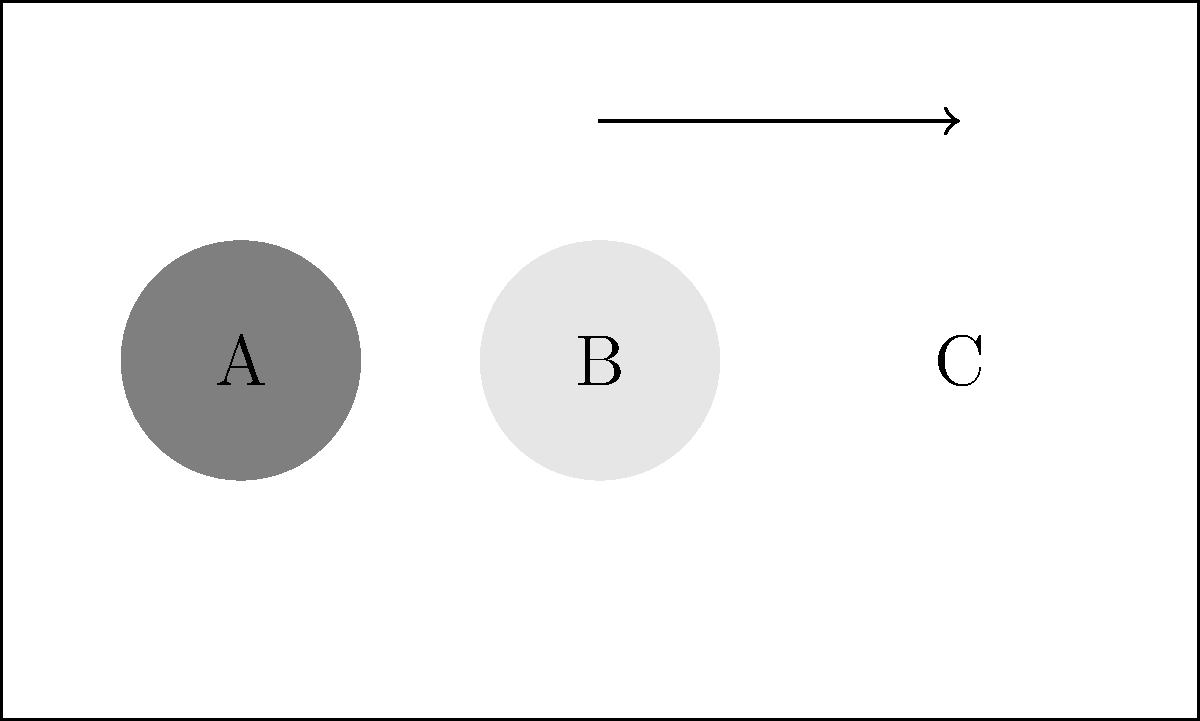You're arranging a display shelf for a new collection of designer accessories. The shelf currently has three circular items placed as shown: a dark gray clutch (A), a light gray wallet (B), and a white handbag (C). To create a more visually appealing display, you decide to rotate the arrangement 90 degrees clockwise. What will be the new order of the accessories from left to right? To solve this spatial rotation problem, let's follow these steps:

1. Identify the current order: The current order from left to right is A (dark gray), B (light gray), C (white).

2. Visualize the rotation: A 90-degree clockwise rotation means the rightmost item will become the leftmost item.

3. Apply the rotation:
   - C (white) will move to the left side
   - A (dark gray) will move to the middle
   - B (light gray) will move to the right side

4. Determine the new order: After rotation, the new order from left to right will be C (white), A (dark gray), B (light gray).

This rotation creates a new visual arrangement that can refresh the display and attract attention to different pieces, which is crucial for a fashion blogger showcasing various accessories.
Answer: C, A, B 